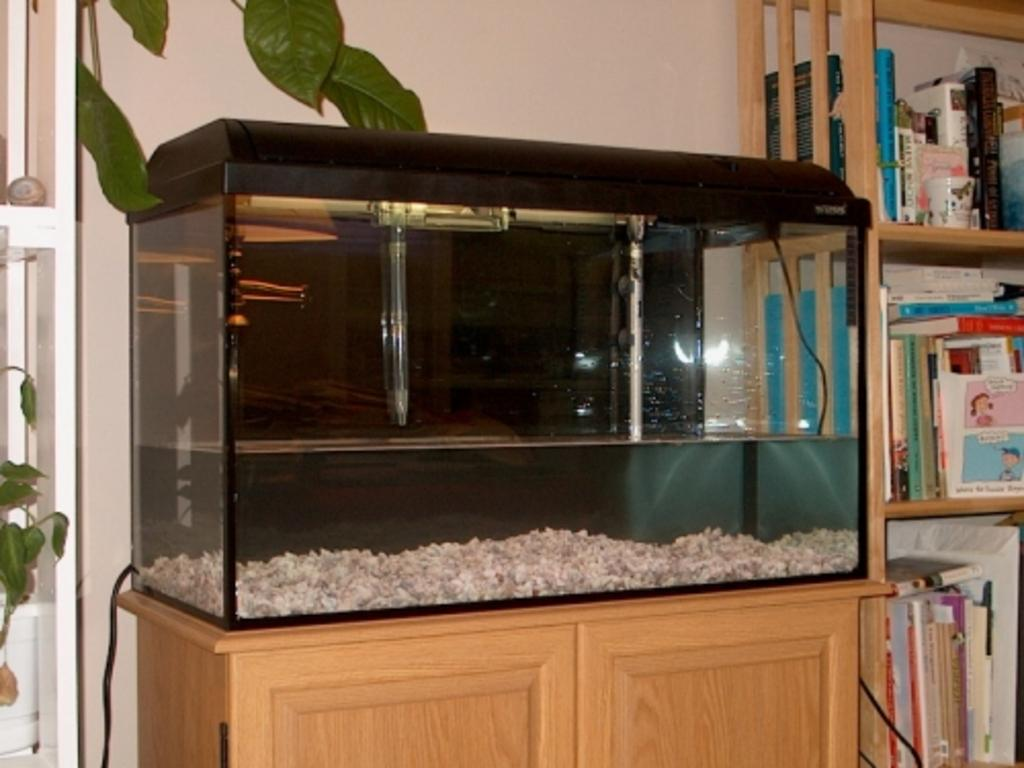What is the main object in the image? There is an aquarium in the image. Where is the aquarium located? The aquarium is on a cabinet. What else can be seen in the image besides the aquarium? There are books and objects in the cupboard. What type of plants are present in the image? Creeper plants are present in the image. Can you tell me how many matches are in the image? There are no matches present in the image. How does the ticket look like in the image? There is no ticket present in the image. 